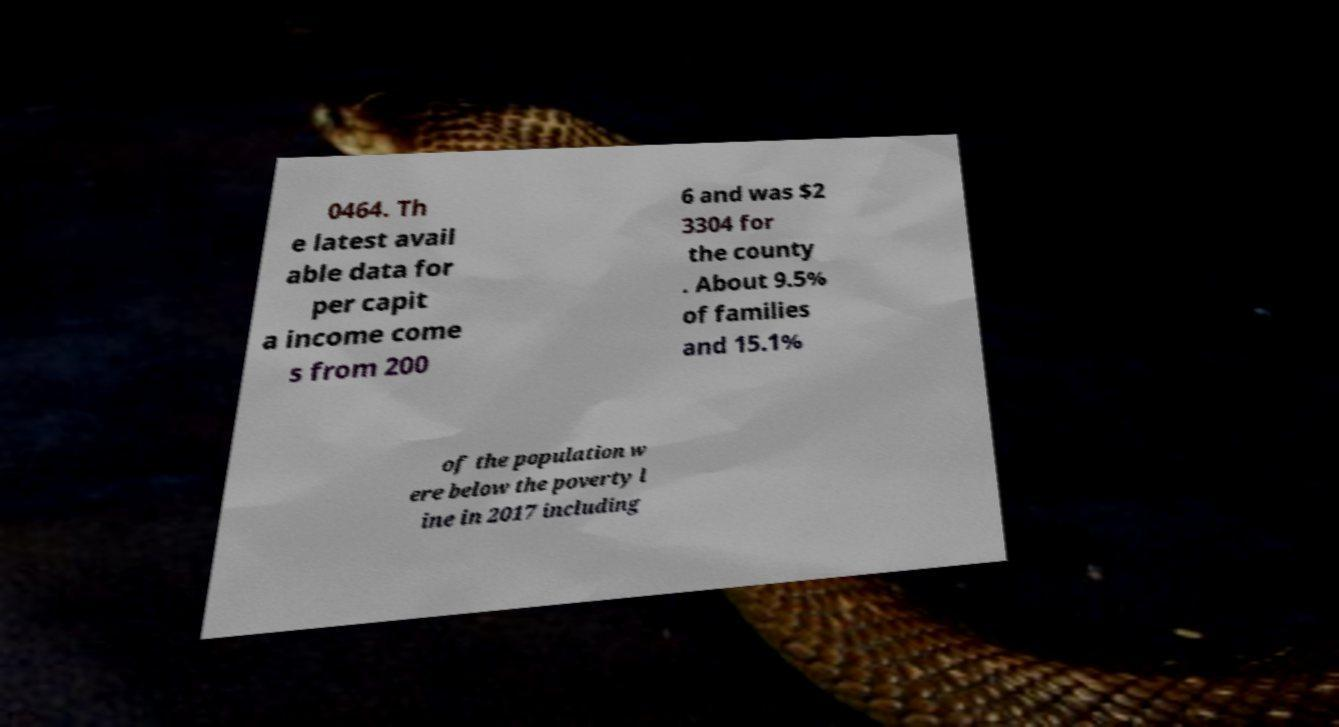Could you assist in decoding the text presented in this image and type it out clearly? 0464. Th e latest avail able data for per capit a income come s from 200 6 and was $2 3304 for the county . About 9.5% of families and 15.1% of the population w ere below the poverty l ine in 2017 including 